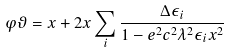<formula> <loc_0><loc_0><loc_500><loc_500>\varphi \vartheta = x + 2 x \sum _ { i } \frac { \Delta \epsilon _ { i } } { 1 - e ^ { 2 } c ^ { 2 } \lambda ^ { 2 } \epsilon _ { i } x ^ { 2 } }</formula> 